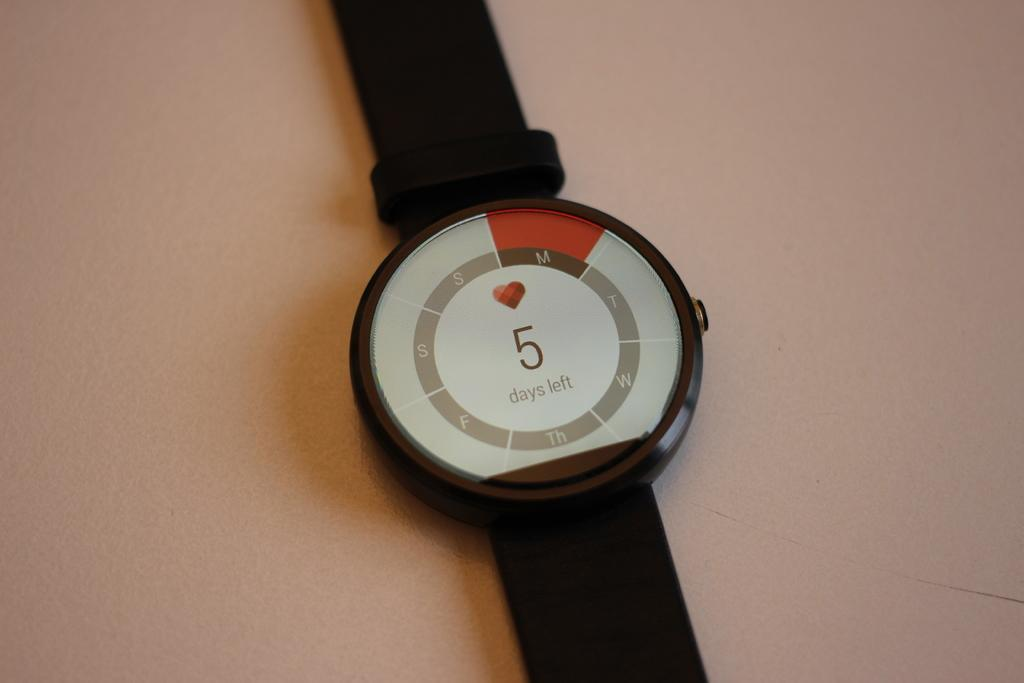<image>
Create a compact narrative representing the image presented. Black and white watch that has a number 5 in the middle. 